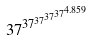Convert formula to latex. <formula><loc_0><loc_0><loc_500><loc_500>3 7 ^ { 3 7 ^ { 3 7 ^ { 3 7 ^ { 3 7 ^ { 4 . 8 5 9 } } } } }</formula> 